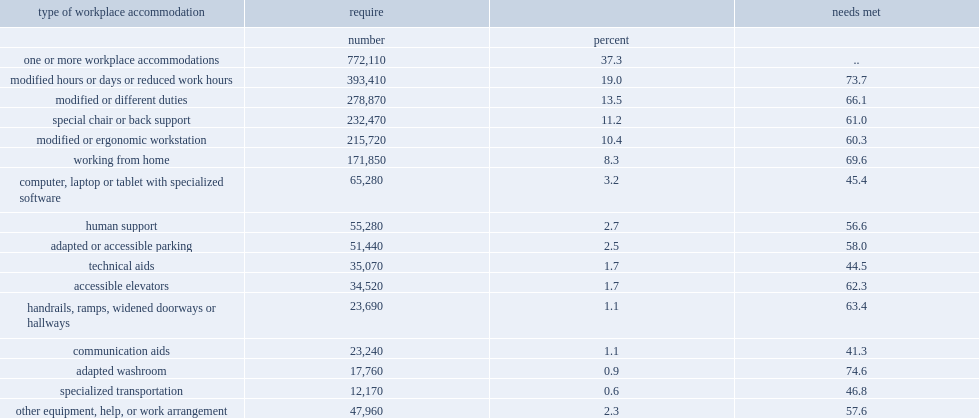According to the 2017 csd,how many employees with disabilities aged 25 to 64 years required at least one workplace accomodations? 772110.0. According to the 2017 csd, how much does employees with disabilities aged 25 to 64 years required at least one workplace accomodations account for the number of disabled employees in canada? 37.3. What was the most frequently required wpa? 19. The need of modified hours or days or reduced work hours was met for how many percent of employees who required it? 73.7. What was one of the least likely wpa to be made available to employees who required it? 44.5. 